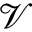Convert formula to latex. <formula><loc_0><loc_0><loc_500><loc_500>\mathcal { V }</formula> 